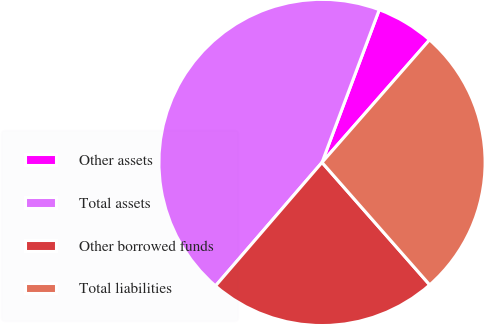Convert chart. <chart><loc_0><loc_0><loc_500><loc_500><pie_chart><fcel>Other assets<fcel>Total assets<fcel>Other borrowed funds<fcel>Total liabilities<nl><fcel>5.75%<fcel>44.38%<fcel>22.81%<fcel>27.06%<nl></chart> 